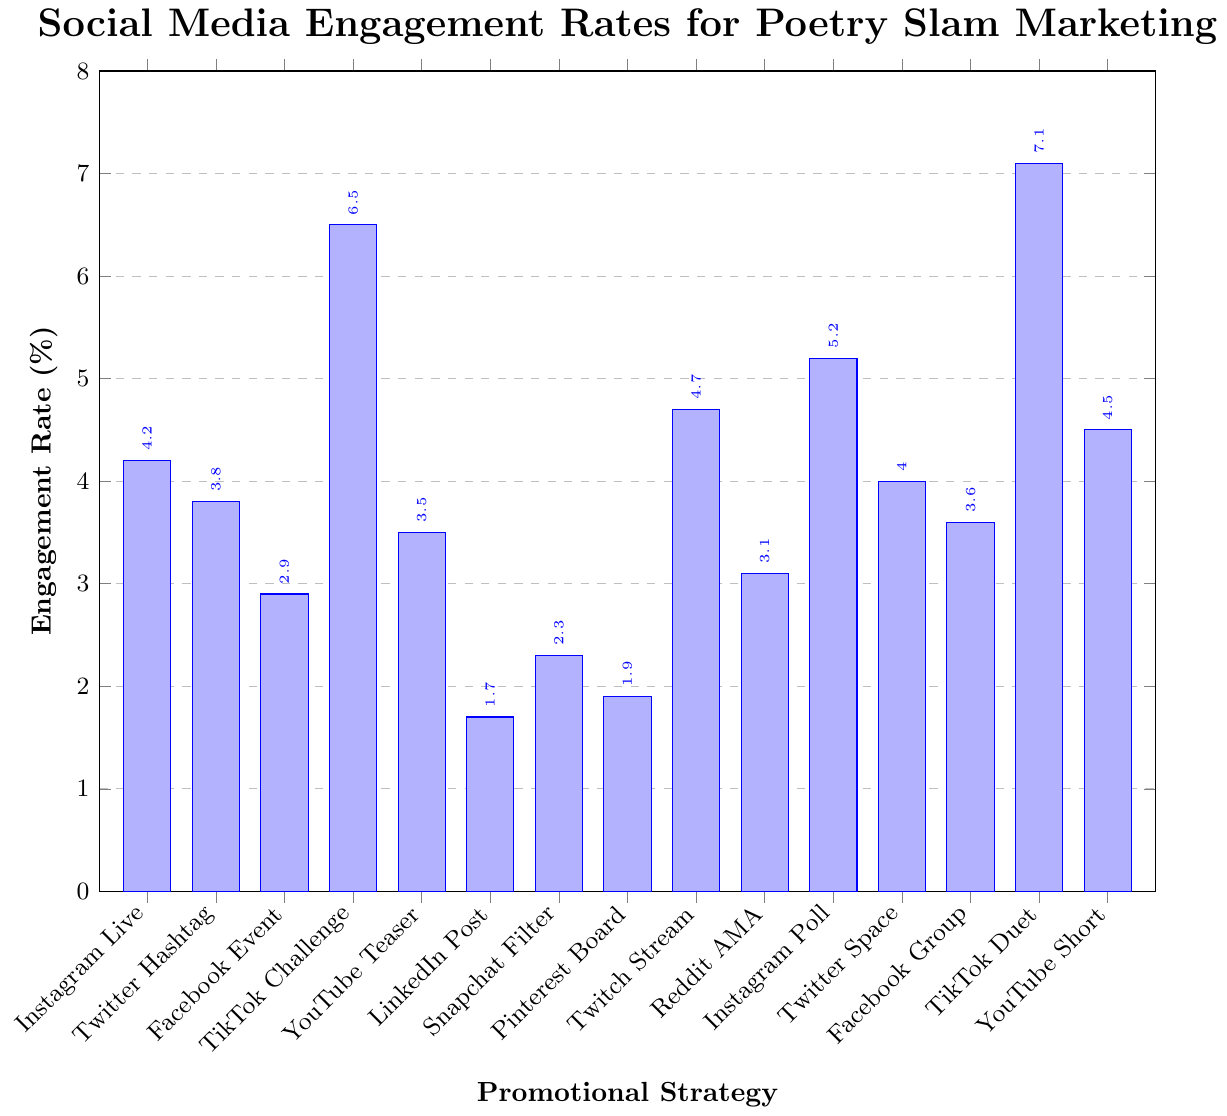what is the promotional strategy with the highest engagement rate? TikTok Duets with Poets has the highest bar, meaning it has the highest engagement rate, which is 7.1%.
Answer: TikTok Duets with Poets Which has a higher engagement rate, Facebook Event Pages or Instagram Live Poetry Readings? Referring to the height of the bars, Instagram Live Poetry Readings has an engagement rate of 4.2%, while Facebook Event Pages has an engagement rate of 2.9%.
Answer: Instagram Live Poetry Readings What is the average engagement rate of strategies involving TikTok? TikTok has two strategies: TikTok Challenges (6.5%) and TikTok Duets with Poets (7.1%). The average is calculated as (6.5 + 7.1) / 2 = 6.8%.
Answer: 6.8% Which two strategies have the most similar engagement rates? Looking at the figure, Twitter Hashtag Campaigns (3.8%) and YouTube Teaser Videos (3.5%) have the closest engagement rates.
Answer: Twitter Hashtag Campaigns and YouTube Teaser Videos What is the total engagement rate for Instagram-based strategies? Instagram has two strategies: Instagram Live Poetry Readings (4.2%) and Instagram Story Polls (5.2%). The total engagement rate is 4.2 + 5.2 = 9.4%.
Answer: 9.4% Which promotional strategy has the lowest engagement rate? The bar for LinkedIn Thought Leadership Posts is the shortest, indicating the lowest engagement rate at 1.7%.
Answer: LinkedIn Thought Leadership Posts How much higher is the engagement rate for TikTok Challenges compared to Facebook Groups for Poetry Enthusiasts? TikTok Challenges has an engagement rate of 6.5%, while Facebook Groups for Poetry Enthusiasts has 3.6%. The difference is 6.5 - 3.6 = 2.9%.
Answer: 2.9% What's the difference in engagement rate between Instagram Story Polls and Snapchat Geo-filters? Instagram Story Polls has an engagement rate of 5.2%, while Snapchat Geo-filters has 2.3%. The difference is 5.2 - 2.3 = 2.9%.
Answer: 2.9% How does the engagement rate of YouTube Shorts of Poem Snippets compare to Reddit AMAs with Featured Poets? YouTube Shorts of Poem Snippets has an engagement rate of 4.5%, while Reddit AMAs with Featured Poets has 3.1%. YouTube Shorts has a higher engagement rate by 4.5 - 3.1 = 1.4%.
Answer: 1.4% Is the engagement rate of Twitter Spaces Discussions closer to Twitch Live Streaming Sessions or YouTube Teaser Videos? Twitter Spaces Discussions have an engagement rate of 4.0%, Twitch Live Streaming Sessions have 4.7%, and YouTube Teaser Videos have 3.5%. The difference between Twitter Spaces and Twitch is 0.7%, while the difference with YouTube is 0.5%, making it closer to YouTube Teaser Videos.
Answer: YouTube Teaser Videos 